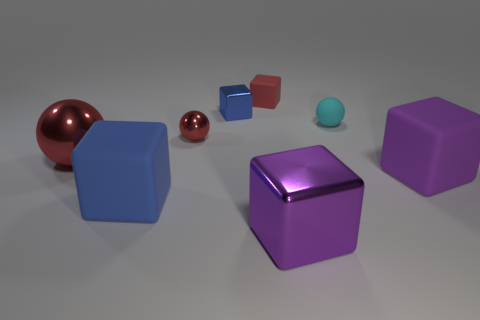Subtract all purple cubes. How many cubes are left? 3 Subtract all big shiny balls. How many balls are left? 2 Subtract 0 yellow spheres. How many objects are left? 8 Subtract all cubes. How many objects are left? 3 Subtract 1 balls. How many balls are left? 2 Subtract all red blocks. Subtract all purple spheres. How many blocks are left? 4 Subtract all yellow cubes. How many red spheres are left? 2 Subtract all large purple metallic things. Subtract all red things. How many objects are left? 4 Add 7 tiny red rubber cubes. How many tiny red rubber cubes are left? 8 Add 2 metal spheres. How many metal spheres exist? 4 